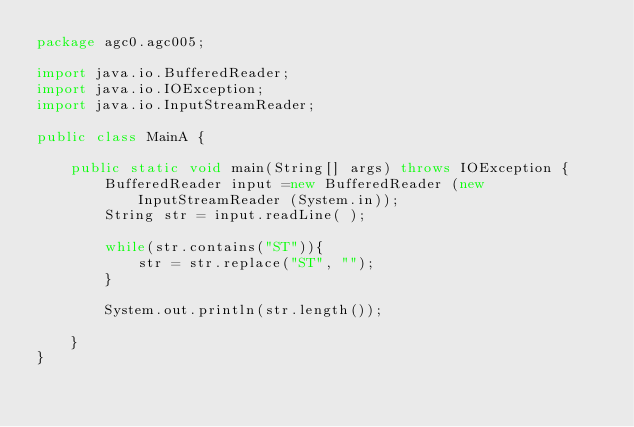<code> <loc_0><loc_0><loc_500><loc_500><_Java_>package agc0.agc005;

import java.io.BufferedReader;
import java.io.IOException;
import java.io.InputStreamReader;

public class MainA {

	public static void main(String[] args) throws IOException {
		BufferedReader input =new BufferedReader (new InputStreamReader (System.in));
		String str = input.readLine( );

		while(str.contains("ST")){
			str = str.replace("ST", "");
		}

		System.out.println(str.length());

	}
}
</code> 